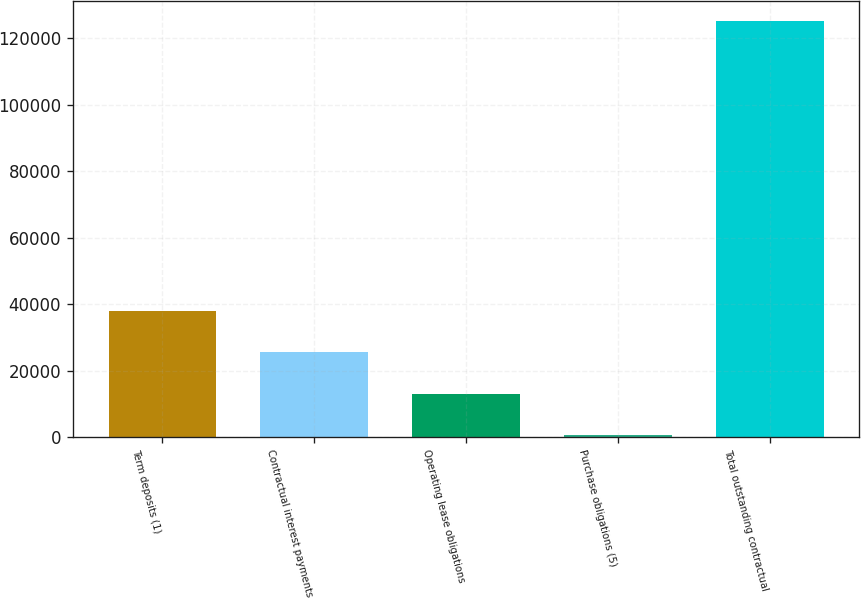Convert chart to OTSL. <chart><loc_0><loc_0><loc_500><loc_500><bar_chart><fcel>Term deposits (1)<fcel>Contractual interest payments<fcel>Operating lease obligations<fcel>Purchase obligations (5)<fcel>Total outstanding contractual<nl><fcel>37941.7<fcel>25496.8<fcel>13051.9<fcel>607<fcel>125056<nl></chart> 